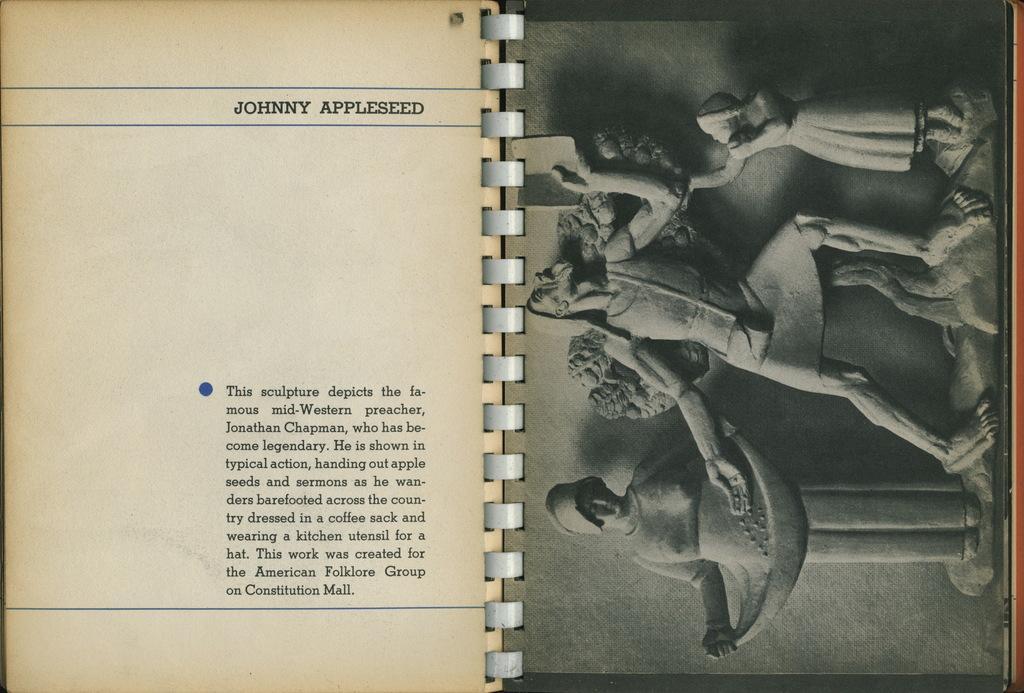Can you describe this image briefly? In this picture we can see pages of a book and on these pages we can see statues and some text. 